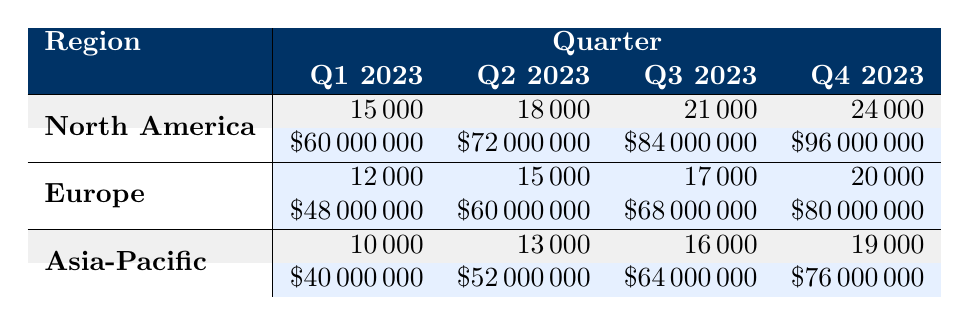What region had the highest revenue in Q4 2023? By reviewing the Q4 2023 row, North America shows a revenue of $96,000,000, which is higher than Europe's $80,000,000 and Asia-Pacific's $76,000,000. Therefore, North America had the highest revenue in that quarter.
Answer: North America What was the total number of units sold in Q2 2023 across all regions? For Q2 2023, North America sold 18,000 units, Europe sold 15,000 units, and Asia-Pacific sold 13,000 units. Summing these gives us 18,000 + 15,000 + 13,000 = 46,000 units.
Answer: 46000 Did Europe sell more units than Asia-Pacific in Q3 2023? In Q3 2023, Europe sold 17,000 units while Asia-Pacific sold 16,000 units. Since 17,000 is greater than 16,000, Europe did sell more units.
Answer: Yes What was the average revenue for North America over all quarters? North America's revenues for the quarters are $60,000,000, $72,000,000, $84,000,000, and $96,000,000. Adding these gives $60,000,000 + $72,000,000 + $84,000,000 + $96,000,000 = $312,000,000. Dividing this total by 4 (the number of quarters) gives us an average of $78,000,000.
Answer: 78000000 Which quarter saw the least sales in the Asia-Pacific region? Looking at the Units Sold for Asia-Pacific for each quarter, they are 10,000 in Q1, 13,000 in Q2, 16,000 in Q3, and 19,000 in Q4. The minimum of these values is 10,000 units sold in Q1.
Answer: Q1 2023 What is the percentage increase in units sold from Q1 2023 to Q4 2023 in North America? North America sold 15,000 units in Q1 2023 and 24,000 units in Q4 2023. The increase in units sold is 24,000 - 15,000 = 9,000. To find the percentage increase, we calculate (9,000 / 15,000) * 100 = 60%.
Answer: 60% Is the total revenue for Europe in 2023 greater than $250 million? The total revenues for Europe in 2023 are $48,000,000 (Q1) + $60,000,000 (Q2) + $68,000,000 (Q3) + $80,000,000 (Q4) = $256,000,000. This total is indeed greater than $250 million.
Answer: Yes How many more units were sold in Q4 2023 than in Q1 2023 across all regions combined? For Q1 2023, units sold were: North America 15,000, Europe 12,000, and Asia-Pacific 10,000, giving a total of 15,000 + 12,000 + 10,000 = 37,000 units. In Q4 2023, units sold were: North America 24,000, Europe 20,000, and Asia-Pacific 19,000, providing a total of 24,000 + 20,000 + 19,000 = 63,000 units. The difference is 63,000 - 37,000 = 26,000 units more sold in Q4.
Answer: 26000 